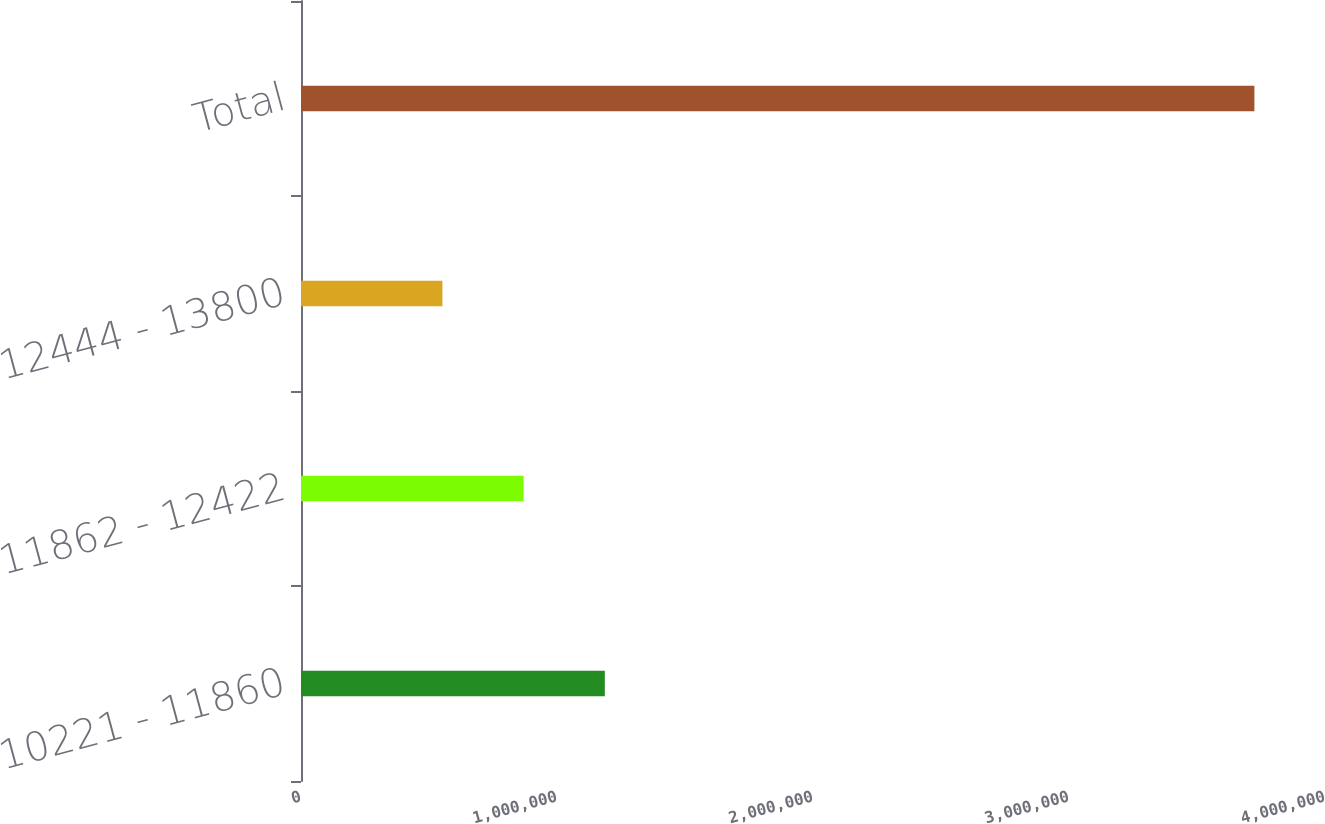<chart> <loc_0><loc_0><loc_500><loc_500><bar_chart><fcel>10221 - 11860<fcel>11862 - 12422<fcel>12444 - 13800<fcel>Total<nl><fcel>1.18681e+06<fcel>869637<fcel>552466<fcel>3.72418e+06<nl></chart> 